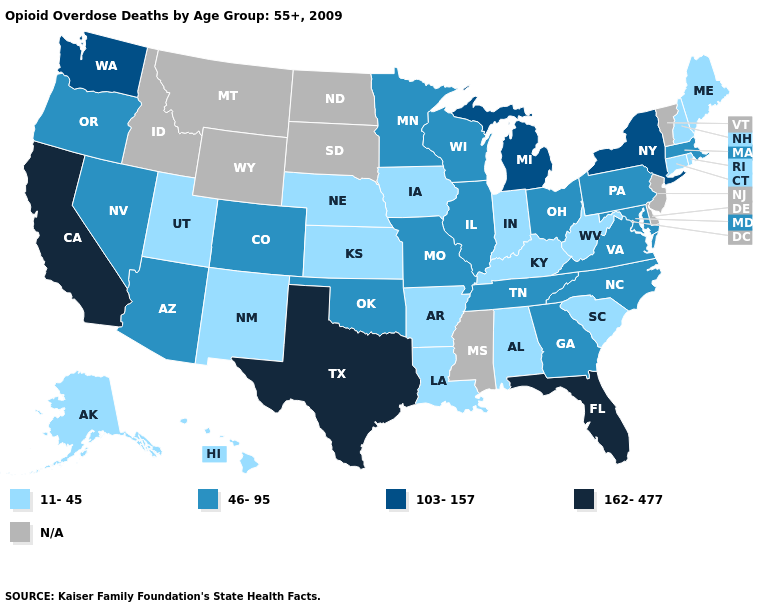What is the highest value in states that border Kansas?
Be succinct. 46-95. Name the states that have a value in the range 103-157?
Quick response, please. Michigan, New York, Washington. What is the value of South Dakota?
Concise answer only. N/A. Name the states that have a value in the range 162-477?
Keep it brief. California, Florida, Texas. What is the lowest value in the MidWest?
Short answer required. 11-45. What is the highest value in the USA?
Be succinct. 162-477. What is the lowest value in states that border Nevada?
Quick response, please. 11-45. Which states have the highest value in the USA?
Short answer required. California, Florida, Texas. What is the lowest value in states that border Rhode Island?
Write a very short answer. 11-45. Which states have the lowest value in the USA?
Answer briefly. Alabama, Alaska, Arkansas, Connecticut, Hawaii, Indiana, Iowa, Kansas, Kentucky, Louisiana, Maine, Nebraska, New Hampshire, New Mexico, Rhode Island, South Carolina, Utah, West Virginia. What is the value of Connecticut?
Short answer required. 11-45. What is the highest value in the West ?
Keep it brief. 162-477. What is the lowest value in the West?
Write a very short answer. 11-45. Name the states that have a value in the range 162-477?
Write a very short answer. California, Florida, Texas. 